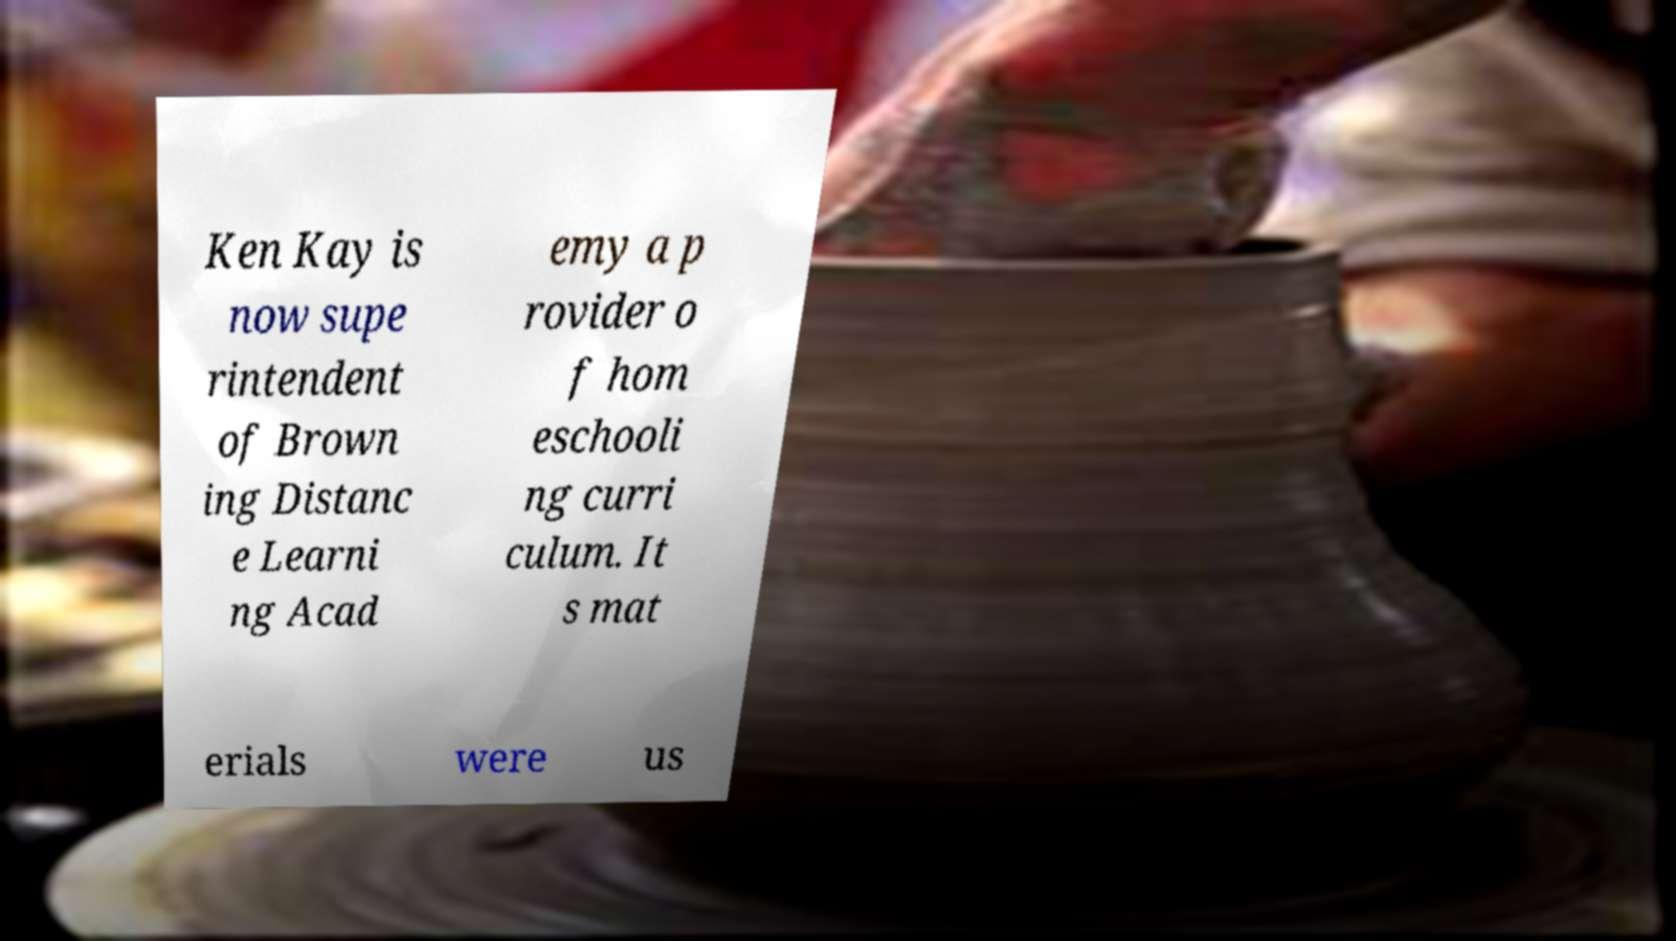Could you extract and type out the text from this image? Ken Kay is now supe rintendent of Brown ing Distanc e Learni ng Acad emy a p rovider o f hom eschooli ng curri culum. It s mat erials were us 